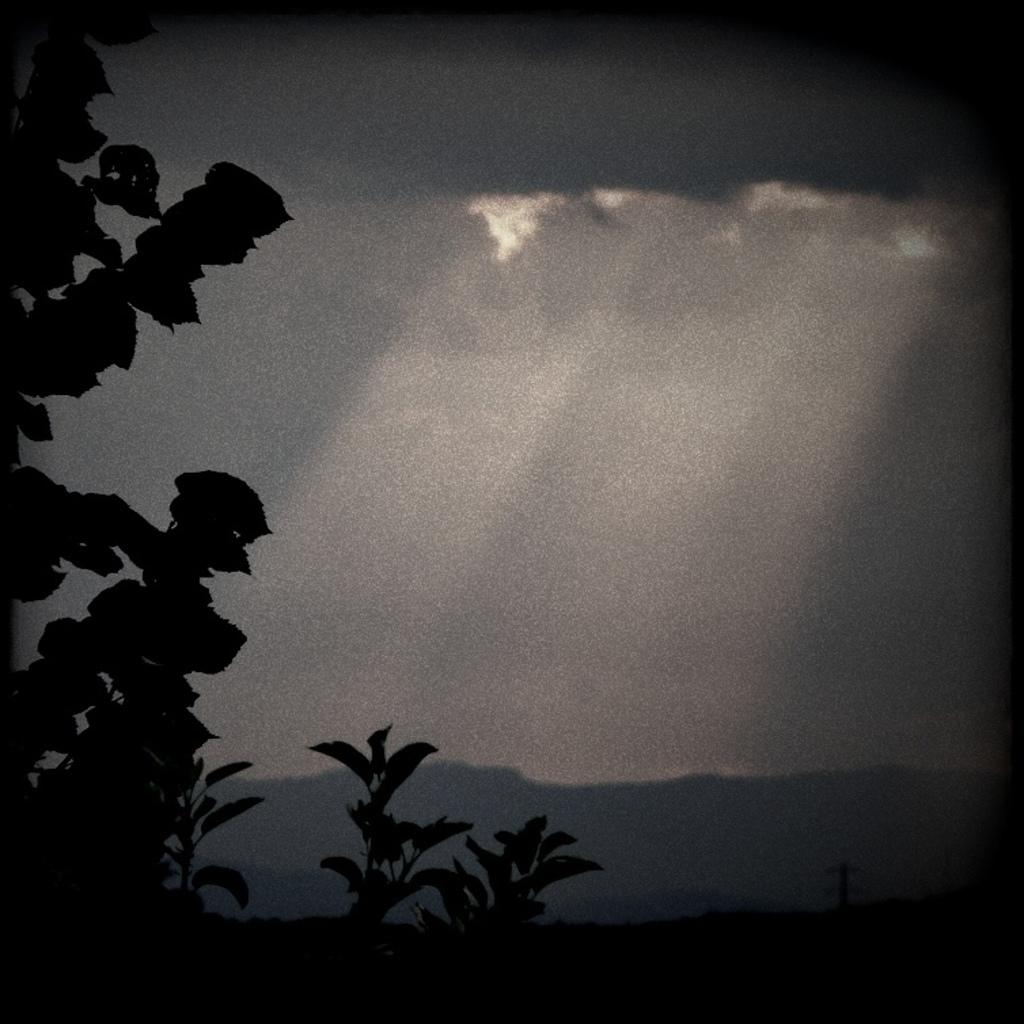What type of living organisms can be seen in the image? Plants can be seen in the image. What can be seen in the background of the image? There are hills visible in the background of the image. What is visible in the sky in the image? The sky is visible in the image, and clouds are present in the sky. What language is the tiger speaking in the image? There is no tiger present in the image, so it is not possible to determine what language it might be speaking. 